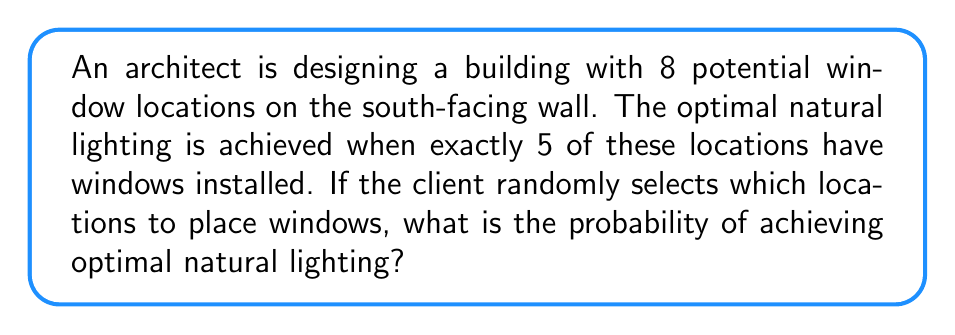Can you answer this question? To solve this problem, we'll use the concept of combinations and probability:

1) First, we need to calculate the total number of ways to choose 5 window locations out of 8 possible locations. This is given by the combination formula:

   $$C(8,5) = \frac{8!}{5!(8-5)!} = \frac{8!}{5!3!}$$

2) Let's calculate this:
   $$\frac{8 \cdot 7 \cdot 6 \cdot 5!}{5! \cdot 3 \cdot 2 \cdot 1} = \frac{336}{6} = 56$$

3) This means there are 56 ways to achieve optimal lighting out of all possible window arrangements.

4) Now, we need to calculate the total number of possible window arrangements. Since each location can either have a window or not (2 choices) and there are 8 locations, the total number of arrangements is:

   $$2^8 = 256$$

5) The probability is then the number of favorable outcomes divided by the total number of possible outcomes:

   $$P(\text{optimal lighting}) = \frac{56}{256} = \frac{7}{32} \approx 0.21875$$

[asy]
size(200);
pen blueprintPen = blue+1;
draw((0,0)--(100,0)--(100,80)--(0,80)--cycle, blueprintPen);
for(int i=0; i<8; ++i) {
  draw((10+i*10,10)--(20+i*10,10)--(20+i*10,20)--(10+i*10,20)--cycle, blueprintPen);
}
label("South-facing wall", (50,-10), S);
[/asy]
Answer: $\frac{7}{32}$ 